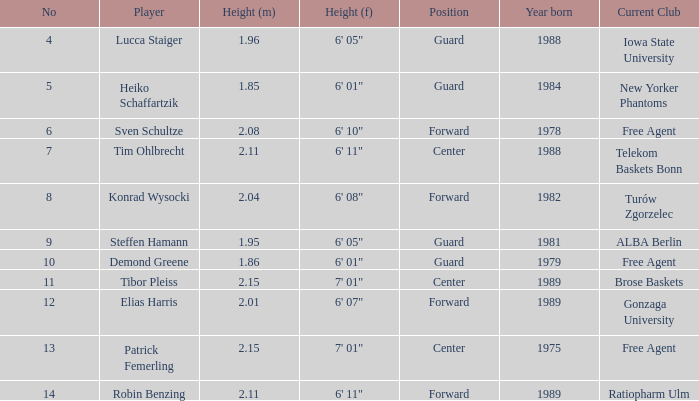11 meters tall. 6' 11". Can you give me this table as a dict? {'header': ['No', 'Player', 'Height (m)', 'Height (f)', 'Position', 'Year born', 'Current Club'], 'rows': [['4', 'Lucca Staiger', '1.96', '6\' 05"', 'Guard', '1988', 'Iowa State University'], ['5', 'Heiko Schaffartzik', '1.85', '6\' 01"', 'Guard', '1984', 'New Yorker Phantoms'], ['6', 'Sven Schultze', '2.08', '6\' 10"', 'Forward', '1978', 'Free Agent'], ['7', 'Tim Ohlbrecht', '2.11', '6\' 11"', 'Center', '1988', 'Telekom Baskets Bonn'], ['8', 'Konrad Wysocki', '2.04', '6\' 08"', 'Forward', '1982', 'Turów Zgorzelec'], ['9', 'Steffen Hamann', '1.95', '6\' 05"', 'Guard', '1981', 'ALBA Berlin'], ['10', 'Demond Greene', '1.86', '6\' 01"', 'Guard', '1979', 'Free Agent'], ['11', 'Tibor Pleiss', '2.15', '7\' 01"', 'Center', '1989', 'Brose Baskets'], ['12', 'Elias Harris', '2.01', '6\' 07"', 'Forward', '1989', 'Gonzaga University'], ['13', 'Patrick Femerling', '2.15', '7\' 01"', 'Center', '1975', 'Free Agent'], ['14', 'Robin Benzing', '2.11', '6\' 11"', 'Forward', '1989', 'Ratiopharm Ulm']]} 